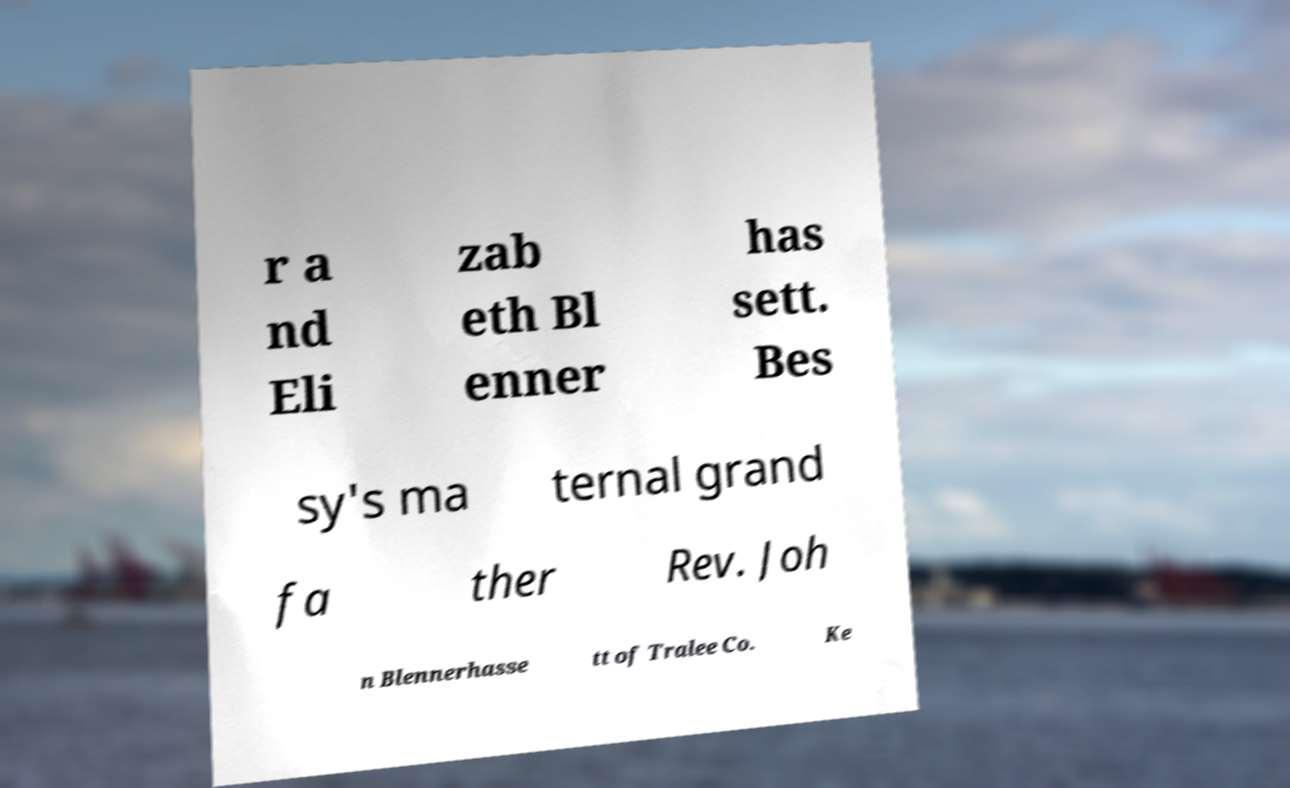Can you read and provide the text displayed in the image?This photo seems to have some interesting text. Can you extract and type it out for me? r a nd Eli zab eth Bl enner has sett. Bes sy's ma ternal grand fa ther Rev. Joh n Blennerhasse tt of Tralee Co. Ke 